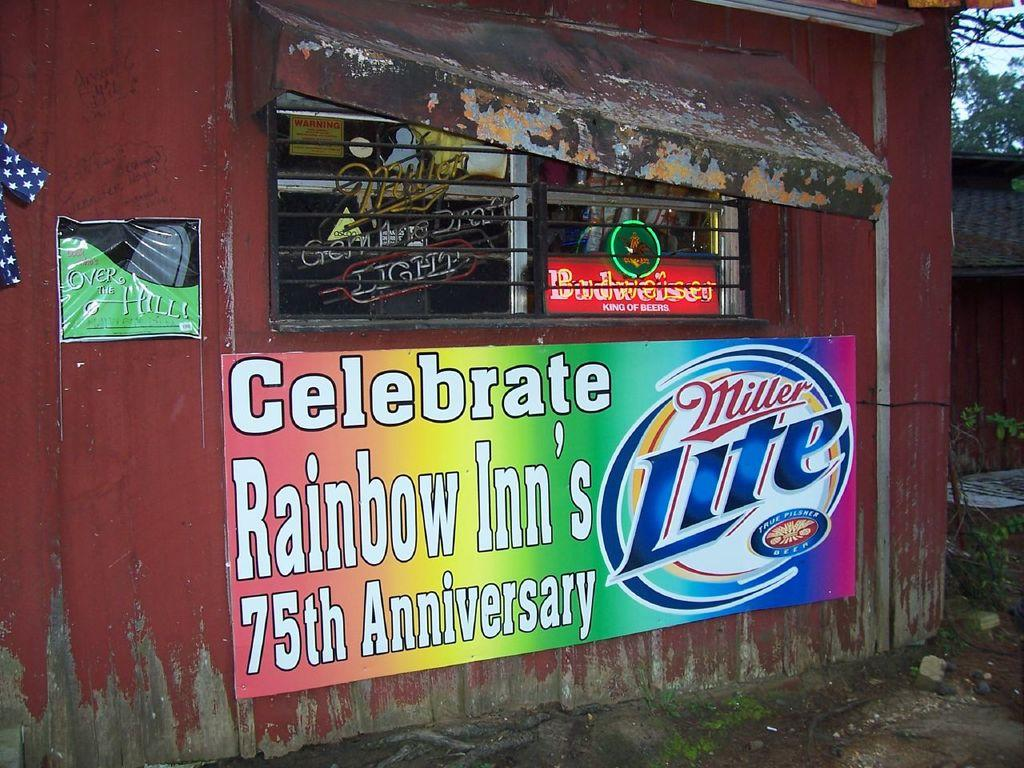<image>
Share a concise interpretation of the image provided. a sign in front of a building that says 'celebrate rainbow inn's 75th anniversary' 